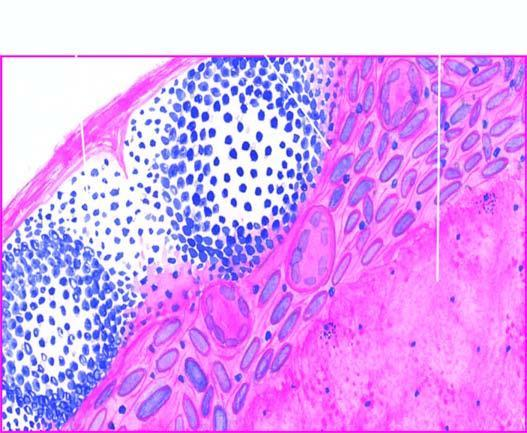what is there eosinophilic, amorphous, granular?
Answer the question using a single word or phrase. Caseous necrosis lymph node 